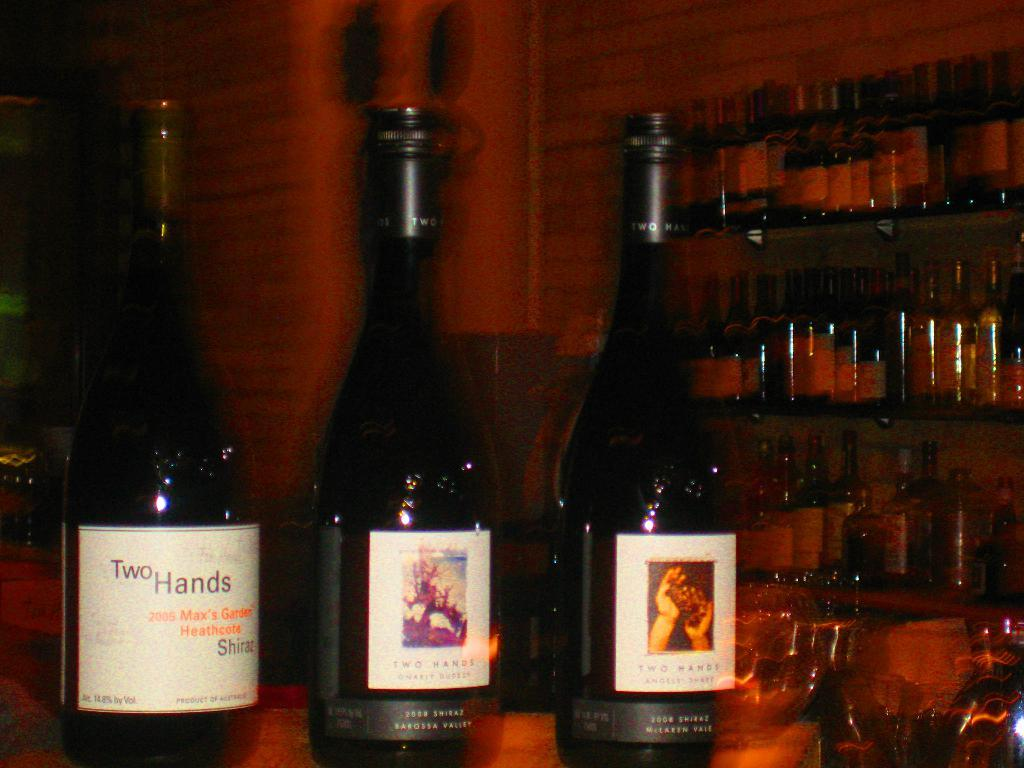Provide a one-sentence caption for the provided image. Three different bottle of Two Hands wine sitting on a bar. 